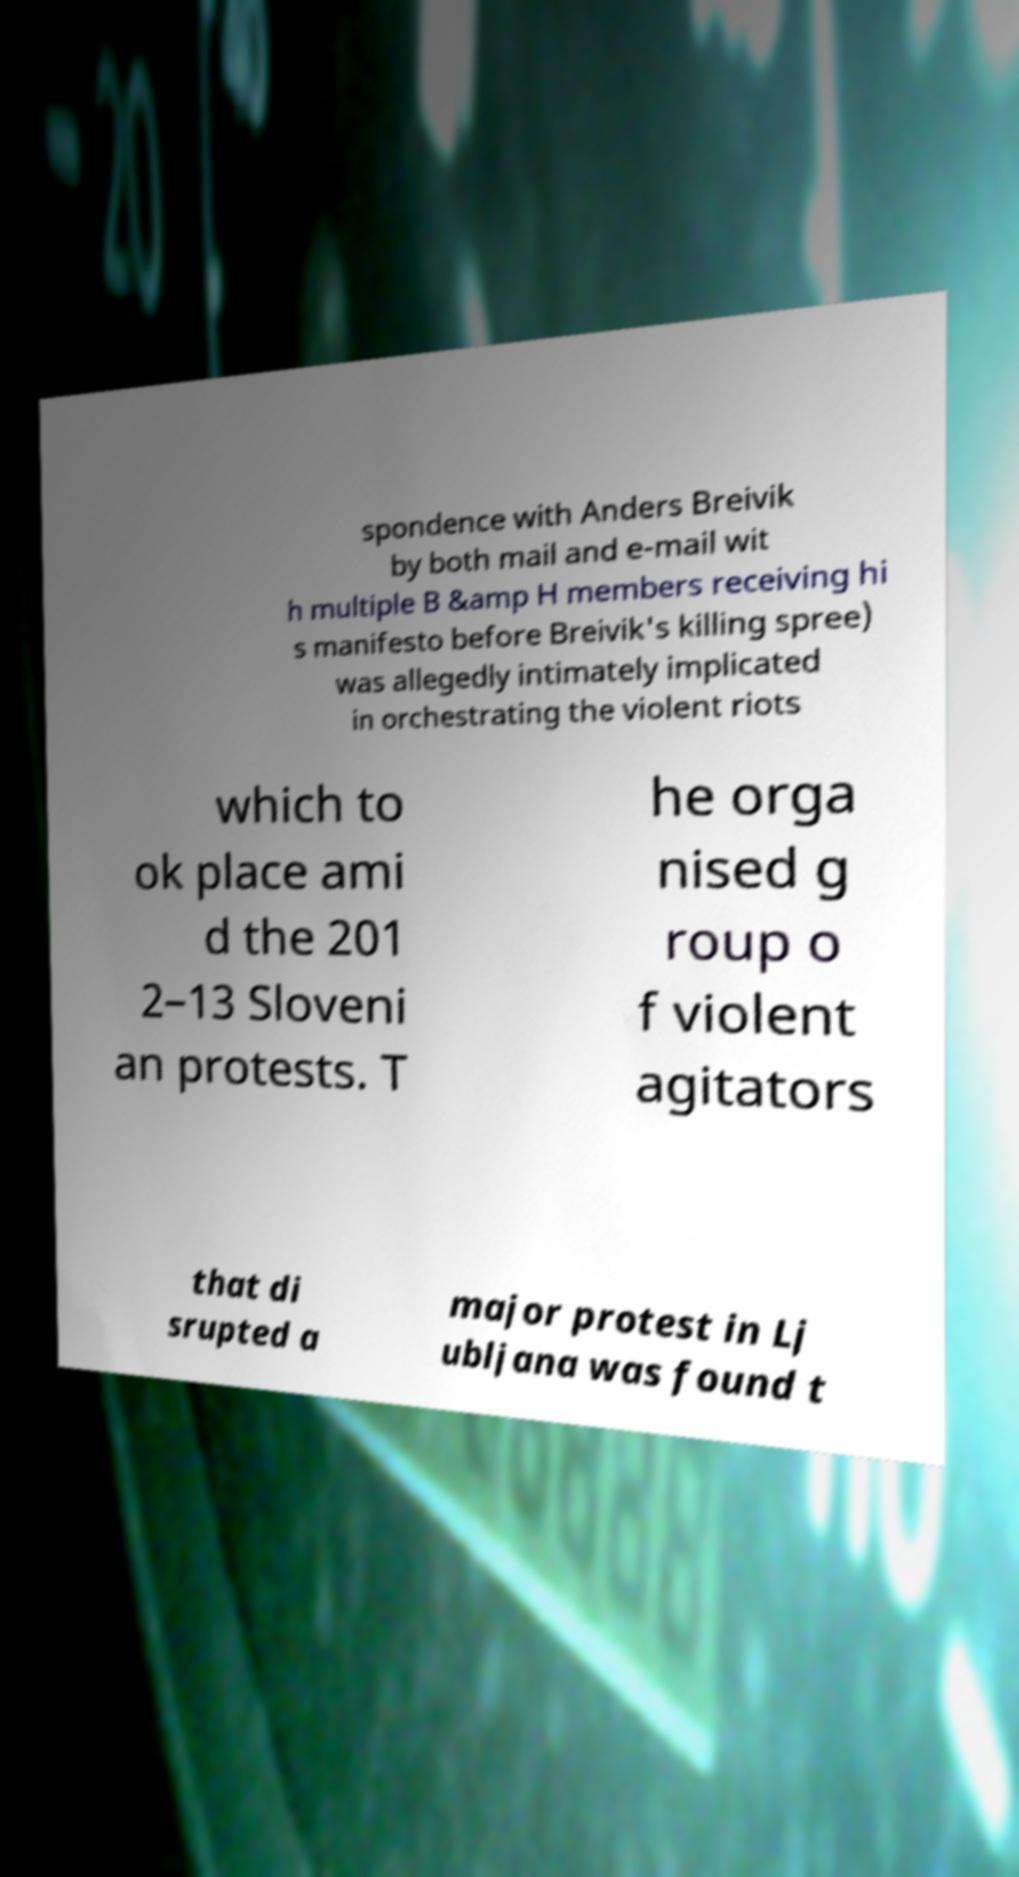Can you read and provide the text displayed in the image?This photo seems to have some interesting text. Can you extract and type it out for me? spondence with Anders Breivik by both mail and e-mail wit h multiple B &amp H members receiving hi s manifesto before Breivik's killing spree) was allegedly intimately implicated in orchestrating the violent riots which to ok place ami d the 201 2–13 Sloveni an protests. T he orga nised g roup o f violent agitators that di srupted a major protest in Lj ubljana was found t 